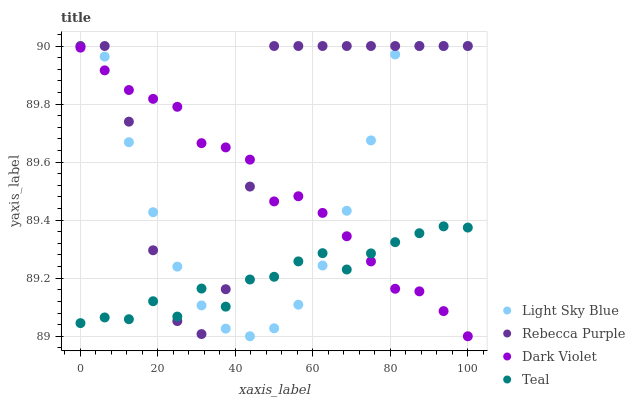Does Teal have the minimum area under the curve?
Answer yes or no. Yes. Does Rebecca Purple have the maximum area under the curve?
Answer yes or no. Yes. Does Light Sky Blue have the minimum area under the curve?
Answer yes or no. No. Does Light Sky Blue have the maximum area under the curve?
Answer yes or no. No. Is Dark Violet the smoothest?
Answer yes or no. Yes. Is Rebecca Purple the roughest?
Answer yes or no. Yes. Is Light Sky Blue the smoothest?
Answer yes or no. No. Is Light Sky Blue the roughest?
Answer yes or no. No. Does Dark Violet have the lowest value?
Answer yes or no. Yes. Does Light Sky Blue have the lowest value?
Answer yes or no. No. Does Rebecca Purple have the highest value?
Answer yes or no. Yes. Does Dark Violet have the highest value?
Answer yes or no. No. Does Rebecca Purple intersect Dark Violet?
Answer yes or no. Yes. Is Rebecca Purple less than Dark Violet?
Answer yes or no. No. Is Rebecca Purple greater than Dark Violet?
Answer yes or no. No. 